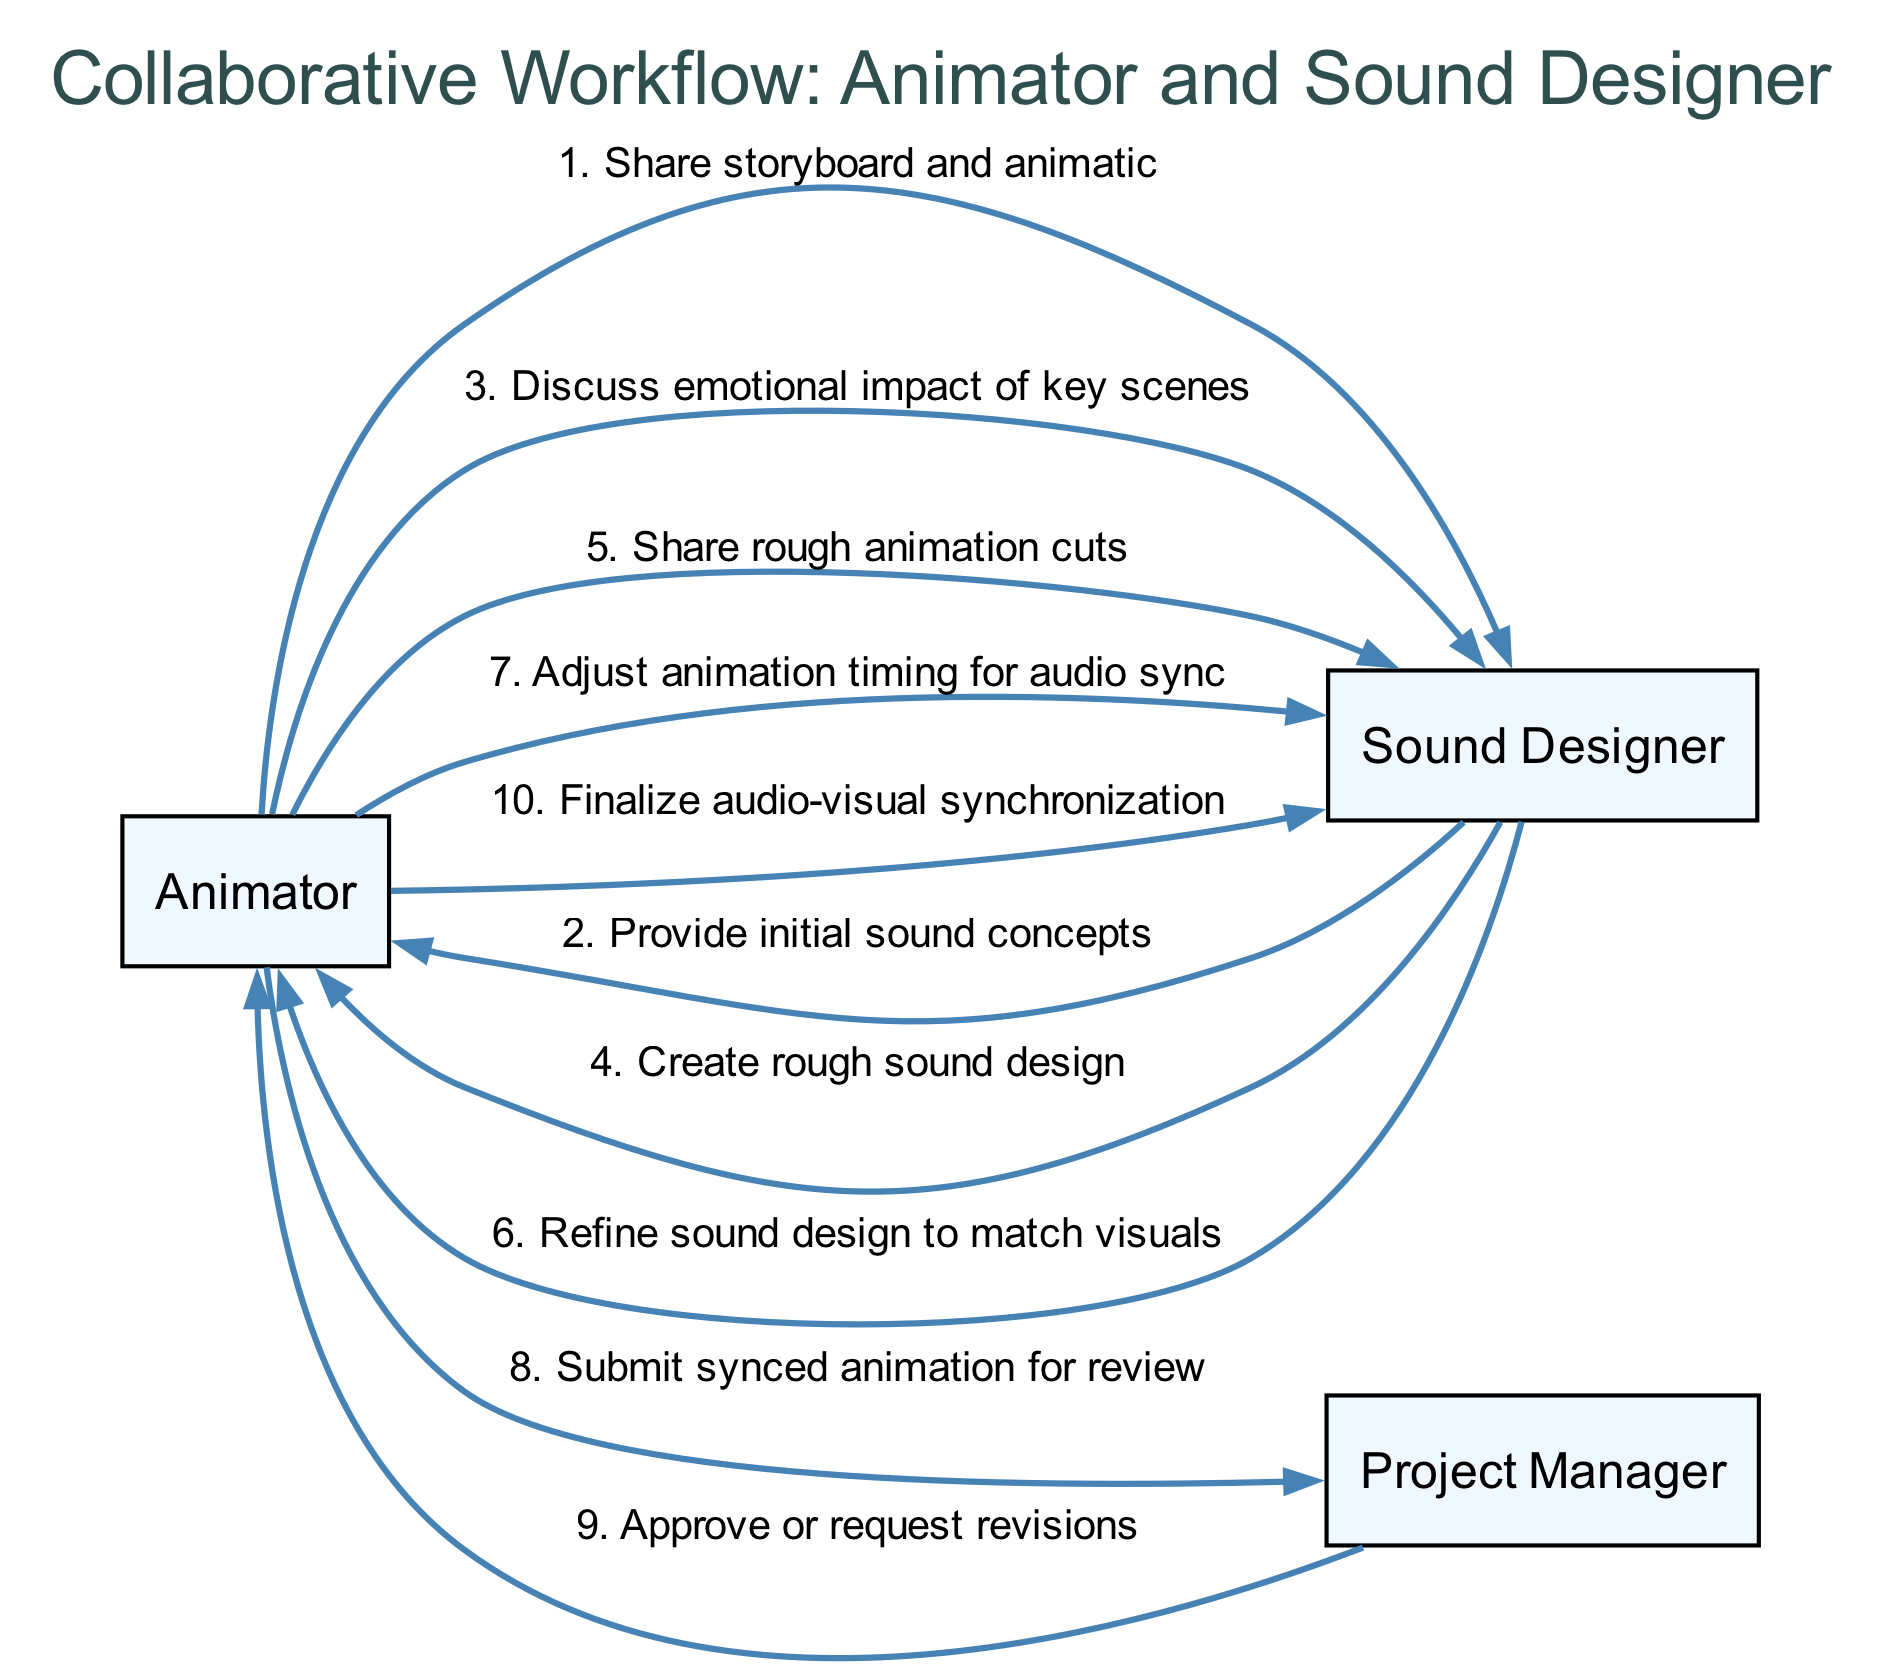What is the first message shared between the Animator and Sound Designer? The first message in the sequence is "Share storyboard and animatic," which is the first edge originating from the Animator to the Sound Designer.
Answer: Share storyboard and animatic How many actors are involved in the workflow? The diagram lists three actors: Animator, Sound Designer, and Project Manager, which are the nodes representing each role in the workflow.
Answer: 3 What is the last action taken by the Animator? The last action is "Finalize audio-visual synchronization," which is the last message sent from the Animator to the Sound Designer in the sequence.
Answer: Finalize audio-visual synchronization Which actor receives the approved synced animation for review? The Project Manager receives the synced animation for review, as indicated by the edge going from the Animator to the Project Manager stating "Submit synced animation for review."
Answer: Project Manager What message does the Sound Designer send after receiving the rough animation cuts? The message sent after the rough animation cuts is "Refine sound design to match visuals," which indicates that the Sound Designer acts on the Animator's previous cut sharing.
Answer: Refine sound design to match visuals Which sequence of actions reflects the collaborative adjustment process? The sequence reflects collaborative adjustment involving the Animator sharing rough animation cuts with the Sound Designer and subsequently the Sound Designer refining sound design to match visuals. This back and forth shows the collaboration in syncing audio to the visuals.
Answer: Adjust animation timing for audio sync What is the total number of messages exchanged between the Animator and Sound Designer? There are six direct messages exchanged between the Animator and Sound Designer, which are specified in the sequence of the diagram.
Answer: 6 In which step does the Project Manager interact with the Animator? The Project Manager interacts with the Animator after the Animator submits the synced animation for review, where the Project Manager either approves or requests revisions.
Answer: Approve or request revisions What is the emotional focus discussed between the Animator and Sound Designer? The focus discussed is the "emotional impact of key scenes," emphasizing the importance of sound in enhancing emotional engagement with the visuals.
Answer: emotional impact of key scenes 